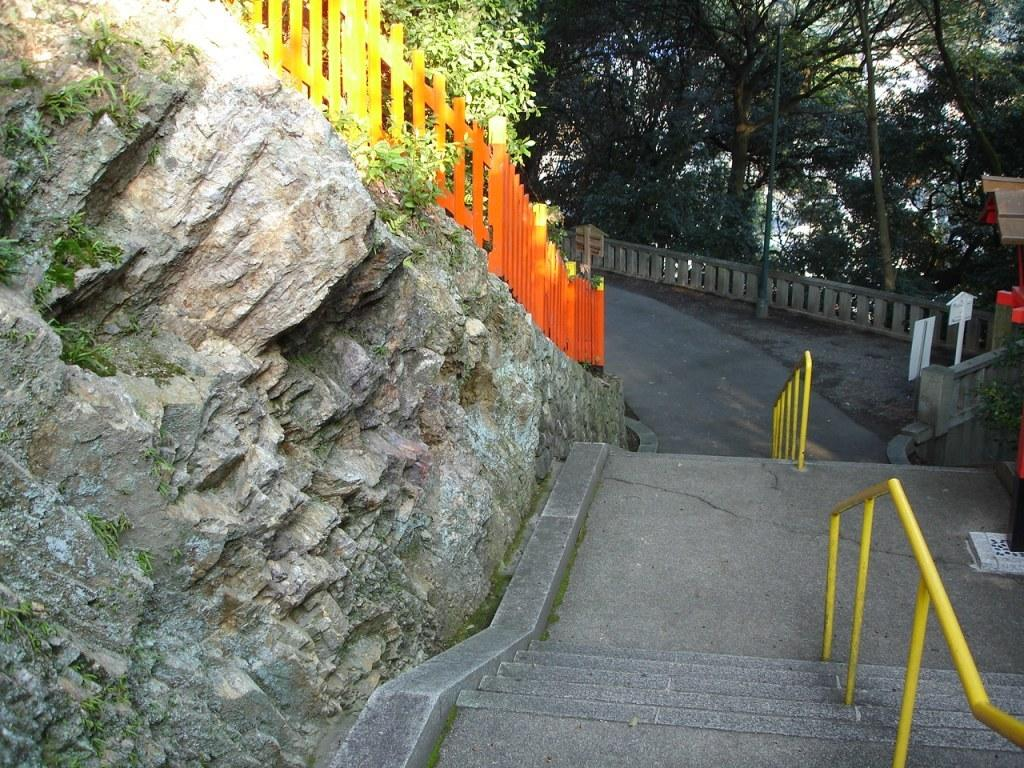What type of fencing is visible in the image? There is wooden fencing in the image. What architectural feature can be seen in the image? There are stairs in the image. What is the purpose of the sign board in the image? The purpose of the sign board in the image is to provide information or directions. What type of vegetation is present in the image? There are trees in the image. How does the lettuce contribute to the overall aesthetic of the image? There is no lettuce present in the image. What emotion is being expressed by the wooden fencing in the image? The wooden fencing does not express any emotion; it is an inanimate object. 